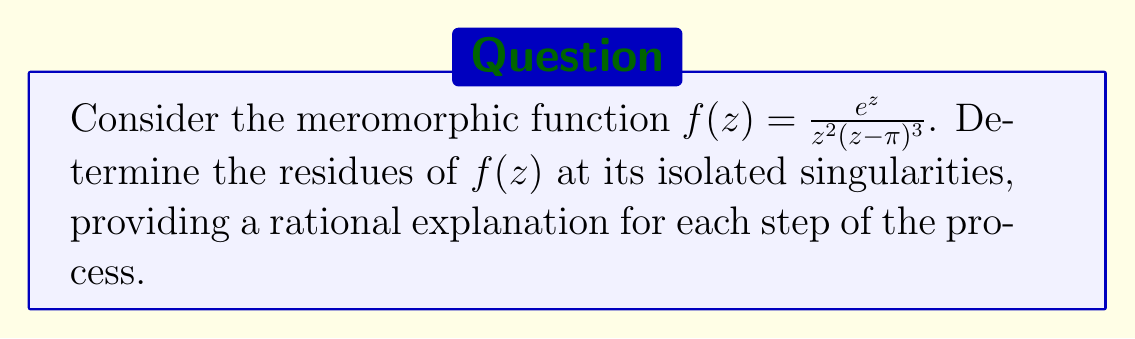Could you help me with this problem? To find the residues of $f(z)$ at its isolated singularities, we need to:

1. Identify the singularities
2. Determine the order of each singularity
3. Calculate the residues using the appropriate method

Step 1: Identify the singularities
The function $f(z)$ has singularities at $z=0$ and $z=\pi$, as these make the denominator zero.

Step 2: Determine the order of each singularity
- At $z=0$, we have a pole of order 2
- At $z=\pi$, we have a pole of order 3

Step 3: Calculate the residues

For $z=0$ (pole of order 2):
We use the formula for the residue at a pole of order 2:
$$\text{Res}(f,0) = \lim_{z\to 0} \frac{d}{dz}\left[z^2f(z)\right]$$

$$\begin{align*}
\text{Res}(f,0) &= \lim_{z\to 0} \frac{d}{dz}\left[\frac{e^z}{(z-\pi)^3}\right] \\
&= \lim_{z\to 0} \frac{e^z(z-\pi)^3 - 3e^z(z-\pi)^2}{(z-\pi)^6} \\
&= \frac{e^0(-\pi)^3 - 3e^0(-\pi)^2}{(-\pi)^6} \\
&= \frac{-\pi^3 + 3\pi^2}{\pi^6} \\
&= \frac{3-\pi}{\pi^5}
\end{align*}$$

For $z=\pi$ (pole of order 3):
We use the formula for the residue at a pole of order 3:
$$\text{Res}(f,\pi) = \frac{1}{2!}\lim_{z\to \pi} \frac{d^2}{dz^2}\left[(z-\pi)^3f(z)\right]$$

$$\begin{align*}
\text{Res}(f,\pi) &= \frac{1}{2!}\lim_{z\to \pi} \frac{d^2}{dz^2}\left[\frac{e^z}{\pi^2}\right] \\
&= \frac{1}{2!}\lim_{z\to \pi} \frac{e^z}{\pi^2} \\
&= \frac{1}{2}\cdot\frac{e^\pi}{\pi^2}
\end{align*}$$

This approach provides a rational explanation for each step, focusing on the mathematical process rather than relying on intuition or faith-based reasoning, which aligns with a pragmatic atheist perspective.
Answer: The residues of $f(z) = \frac{e^z}{z^2(z-\pi)^3}$ at its isolated singularities are:

At $z=0$: $\text{Res}(f,0) = \frac{3-\pi}{\pi^5}$

At $z=\pi$: $\text{Res}(f,\pi) = \frac{e^\pi}{2\pi^2}$ 